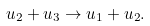<formula> <loc_0><loc_0><loc_500><loc_500>u _ { 2 } + u _ { 3 } \to u _ { 1 } + u _ { 2 } .</formula> 